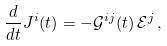Convert formula to latex. <formula><loc_0><loc_0><loc_500><loc_500>\frac { d } { d t } J ^ { i } ( t ) = - \mathcal { G } ^ { i j } ( t ) \, \mathcal { E } ^ { j } \, ,</formula> 